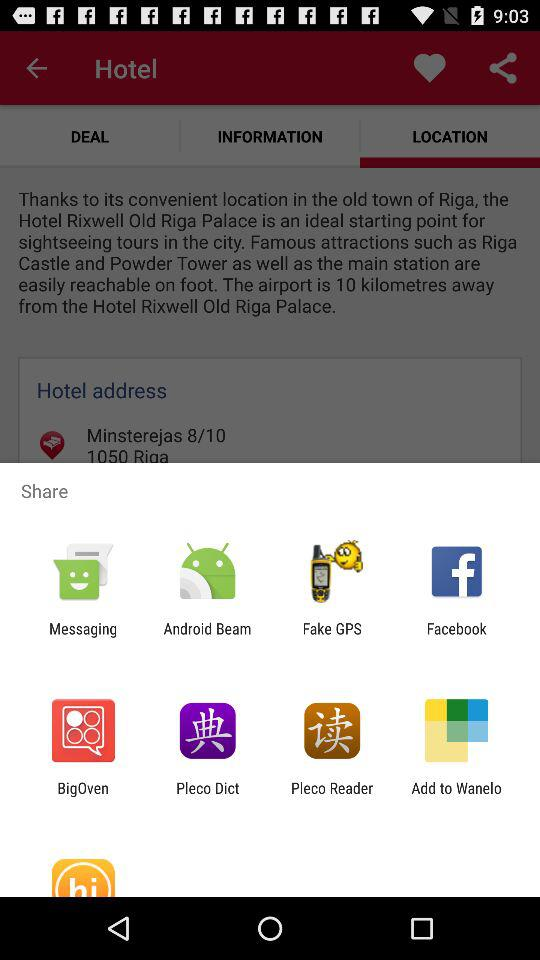What is the address of the hotel? The address of the hotel is Minsterejas 8/10, 1050 Riga. 